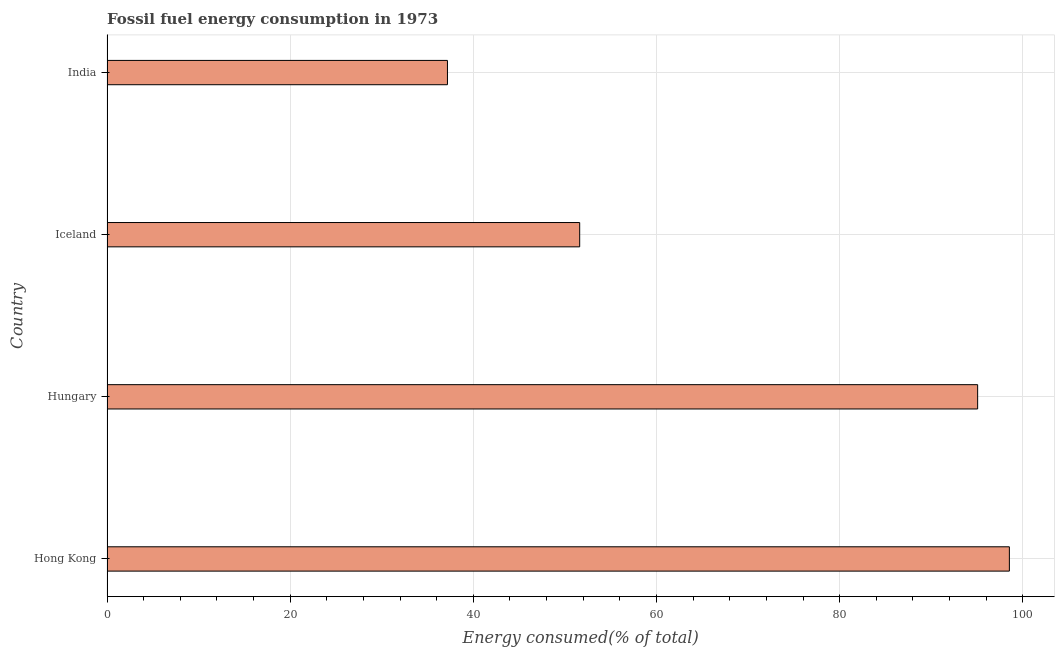Does the graph contain grids?
Ensure brevity in your answer.  Yes. What is the title of the graph?
Keep it short and to the point. Fossil fuel energy consumption in 1973. What is the label or title of the X-axis?
Make the answer very short. Energy consumed(% of total). What is the label or title of the Y-axis?
Offer a terse response. Country. What is the fossil fuel energy consumption in Hong Kong?
Make the answer very short. 98.53. Across all countries, what is the maximum fossil fuel energy consumption?
Provide a succinct answer. 98.53. Across all countries, what is the minimum fossil fuel energy consumption?
Offer a very short reply. 37.17. In which country was the fossil fuel energy consumption maximum?
Keep it short and to the point. Hong Kong. In which country was the fossil fuel energy consumption minimum?
Your answer should be compact. India. What is the sum of the fossil fuel energy consumption?
Your response must be concise. 282.39. What is the difference between the fossil fuel energy consumption in Hong Kong and India?
Keep it short and to the point. 61.36. What is the average fossil fuel energy consumption per country?
Provide a succinct answer. 70.6. What is the median fossil fuel energy consumption?
Provide a short and direct response. 73.34. What is the ratio of the fossil fuel energy consumption in Iceland to that in India?
Your response must be concise. 1.39. What is the difference between the highest and the second highest fossil fuel energy consumption?
Offer a terse response. 3.46. Is the sum of the fossil fuel energy consumption in Hong Kong and Hungary greater than the maximum fossil fuel energy consumption across all countries?
Keep it short and to the point. Yes. What is the difference between the highest and the lowest fossil fuel energy consumption?
Give a very brief answer. 61.36. Are all the bars in the graph horizontal?
Ensure brevity in your answer.  Yes. How many countries are there in the graph?
Your answer should be compact. 4. What is the Energy consumed(% of total) in Hong Kong?
Offer a terse response. 98.53. What is the Energy consumed(% of total) in Hungary?
Ensure brevity in your answer.  95.07. What is the Energy consumed(% of total) of Iceland?
Your answer should be very brief. 51.61. What is the Energy consumed(% of total) in India?
Provide a succinct answer. 37.17. What is the difference between the Energy consumed(% of total) in Hong Kong and Hungary?
Offer a very short reply. 3.46. What is the difference between the Energy consumed(% of total) in Hong Kong and Iceland?
Your response must be concise. 46.92. What is the difference between the Energy consumed(% of total) in Hong Kong and India?
Your answer should be compact. 61.36. What is the difference between the Energy consumed(% of total) in Hungary and Iceland?
Provide a succinct answer. 43.45. What is the difference between the Energy consumed(% of total) in Hungary and India?
Make the answer very short. 57.89. What is the difference between the Energy consumed(% of total) in Iceland and India?
Keep it short and to the point. 14.44. What is the ratio of the Energy consumed(% of total) in Hong Kong to that in Hungary?
Provide a succinct answer. 1.04. What is the ratio of the Energy consumed(% of total) in Hong Kong to that in Iceland?
Your answer should be very brief. 1.91. What is the ratio of the Energy consumed(% of total) in Hong Kong to that in India?
Provide a short and direct response. 2.65. What is the ratio of the Energy consumed(% of total) in Hungary to that in Iceland?
Provide a succinct answer. 1.84. What is the ratio of the Energy consumed(% of total) in Hungary to that in India?
Make the answer very short. 2.56. What is the ratio of the Energy consumed(% of total) in Iceland to that in India?
Make the answer very short. 1.39. 